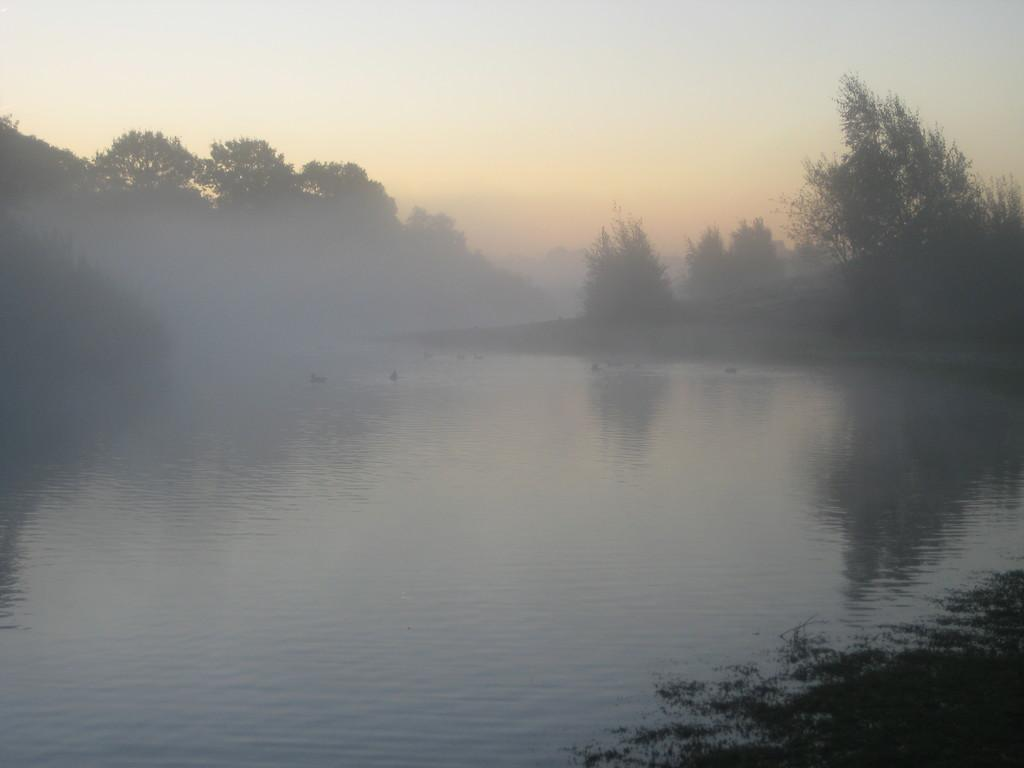What is visible in the image? Water, trees, and the sky are visible in the image. Can you describe the natural setting in the image? The natural setting includes water, trees, and the sky. What is the condition of the sky in the image? The sky is visible in the background of the image. How many eggs are floating in the water in the image? There are no eggs visible in the water in the image. What type of health benefits can be gained from the trees in the image? The image does not provide information about the health benefits of the trees. 